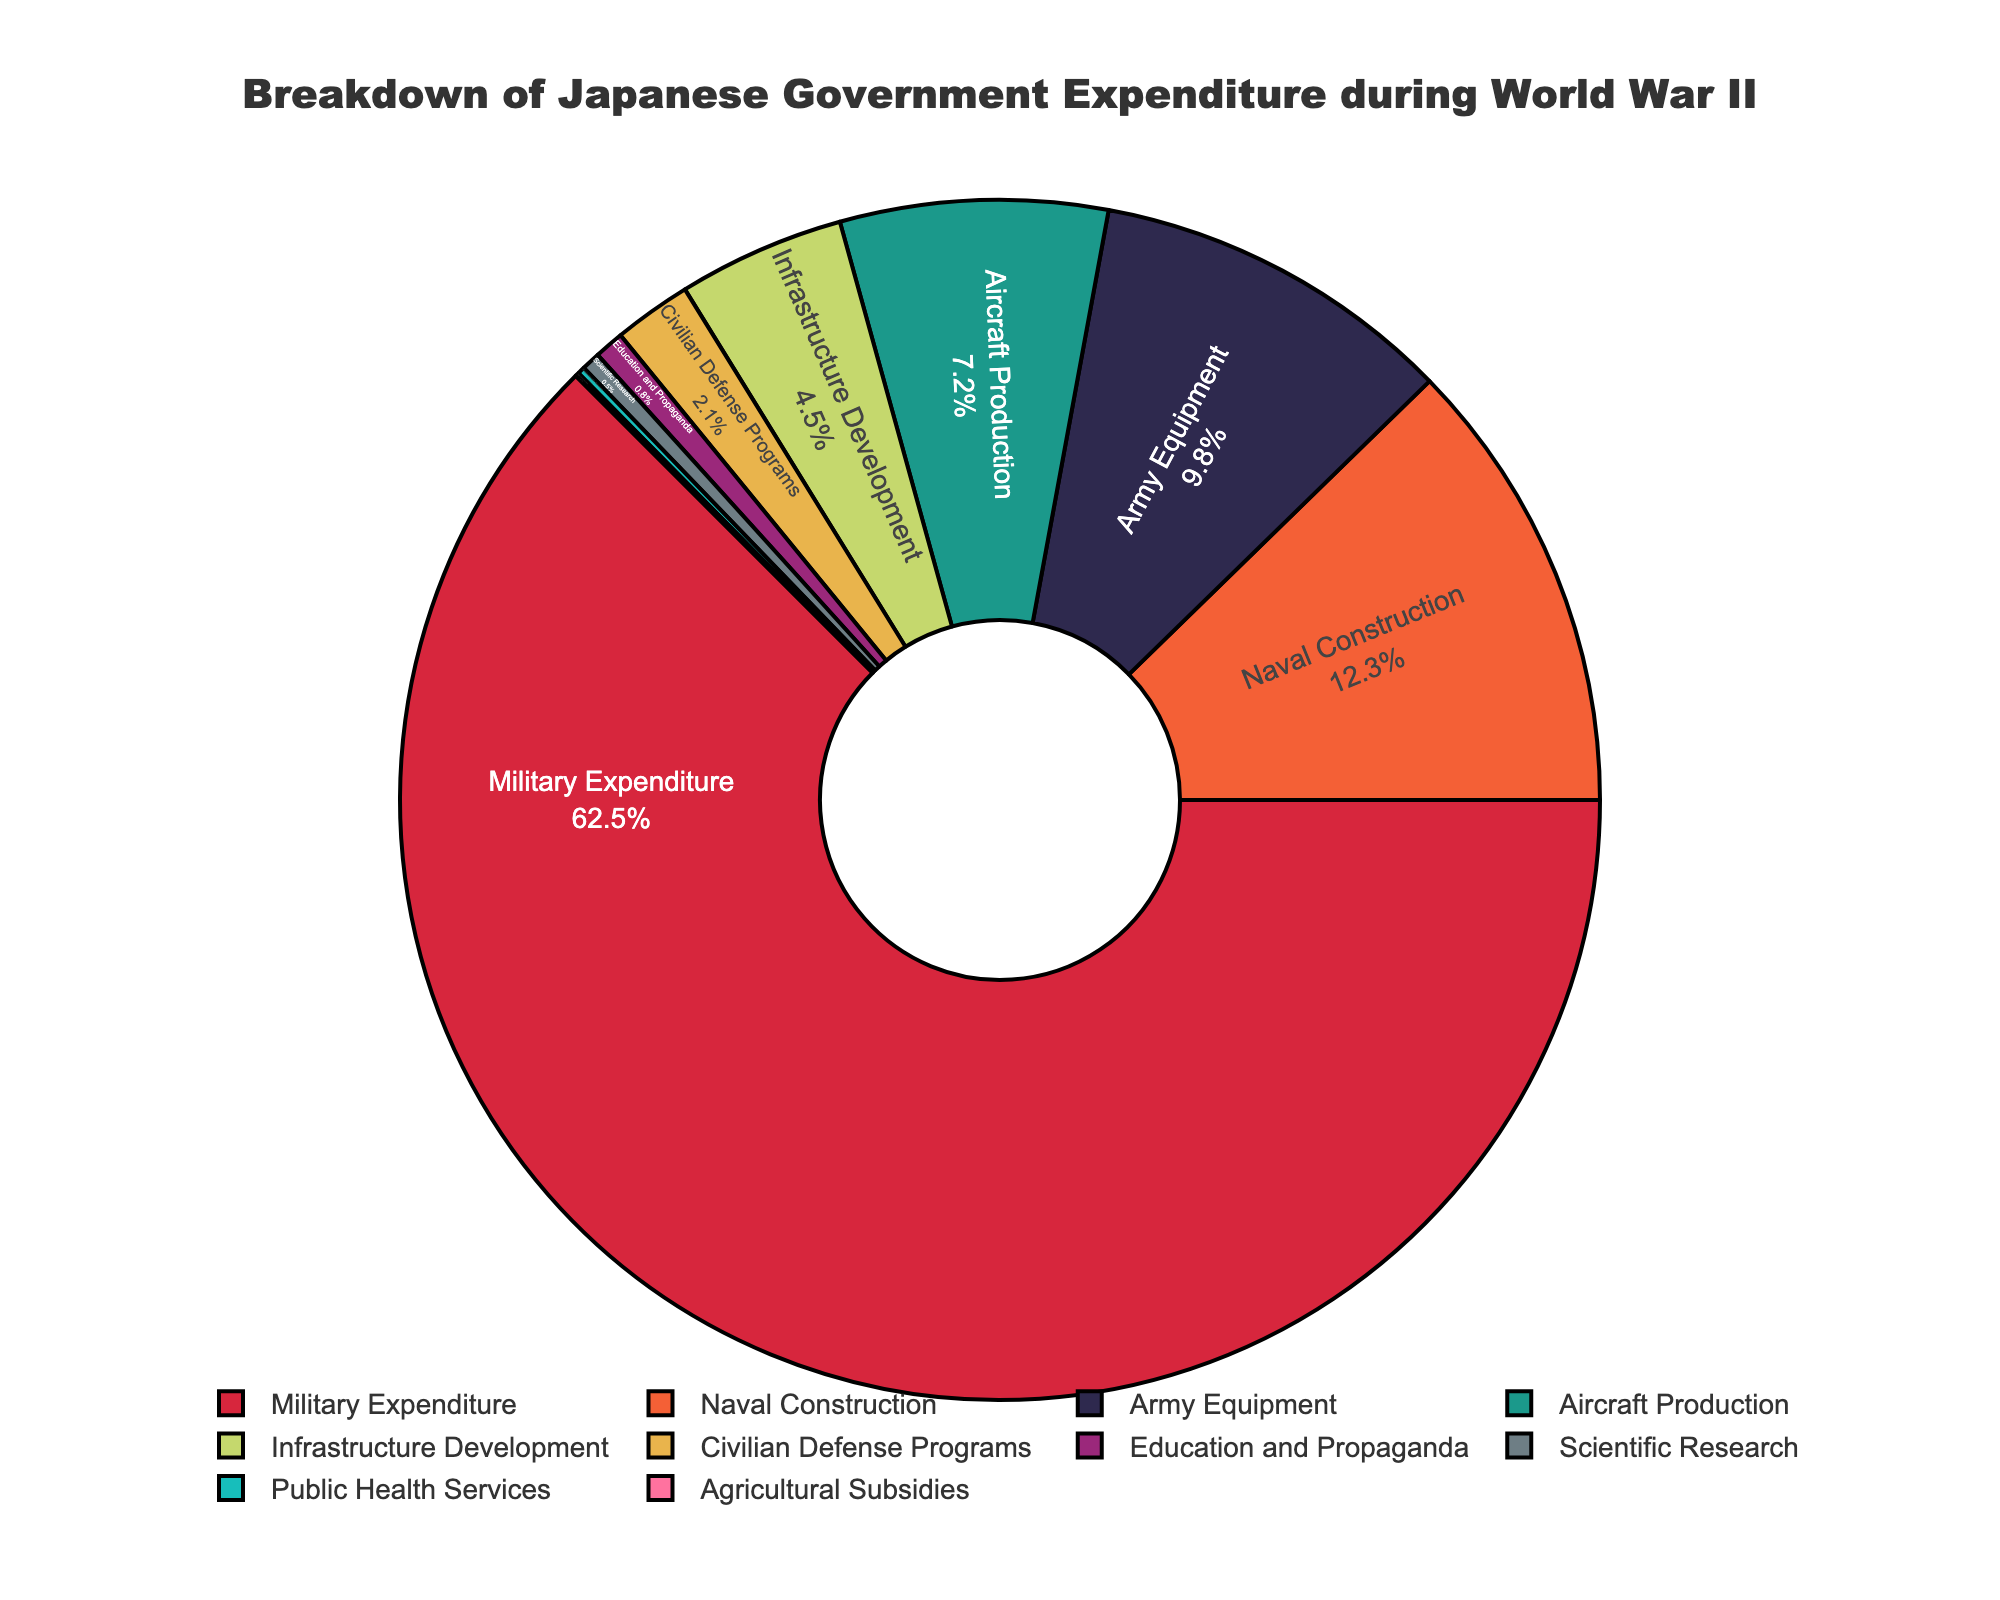Which category has the highest percentage of government expenditure during World War II? The largest segment of the pie chart corresponds to the Military Expenditure category, indicating the highest percentage.
Answer: Military Expenditure How much higher is the Military Expenditure compared to Naval Construction? Military Expenditure is 62.5%, and Naval Construction is 12.3%. Subtracting these values gives (62.5 - 12.3) = 50.2%.
Answer: 50.2% What is the combined percentage of Naval Construction, Army Equipment, and Aircraft Production? Adding the values for Naval Construction (12.3%), Army Equipment (9.8%), and Aircraft Production (7.2%) results in (12.3 + 9.8 + 7.2) = 29.3%.
Answer: 29.3% Which sectors combined have a total expenditure percentage lower than Infrastructure Development? Adding the percentages for Public Health Services (0.2%) and Agricultural Subsidies (0.1%) results in (0.2 + 0.1) = 0.3%, which is lower than Infrastructure Development's 4.5%.
Answer: Public Health Services and Agricultural Subsidies How does the expenditure on Aircraft Production compare to that on Education and Propaganda? The expenditure on Aircraft Production is 7.2%, while on Education and Propaganda, it is 0.8%, making Aircraft Production (7.2 - 0.8) = 6.4% higher.
Answer: 6.4% higher What is the total percentage allocated to categories that are not directly related to military spending? Summing the percentages for Infrastructure Development (4.5%), Civilian Defense Programs (2.1%), Education and Propaganda (0.8%), Scientific Research (0.5%), Public Health Services (0.2%), and Agricultural Subsidies (0.1%) results in (4.5 + 2.1 + 0.8 + 0.5 + 0.2 + 0.1) = 8.2%.
Answer: 8.2% Among the listed categories, which one has the smallest allocation and what is its value? The smallest segment of the pie chart corresponds to Agricultural Subsidies with a value of 0.1%.
Answer: Agricultural Subsidies, 0.1% Is the percentage of expenditure on Scientific Research and Public Health Services combined greater than that of Civilian Defense Programs? Adding the percentages for Scientific Research (0.5%) and Public Health Services (0.2%) results in (0.5 + 0.2) = 0.7%, which is less than the percentage for Civilian Defense Programs (2.1%).
Answer: No, 0.7% is less than 2.1% Which category is represented by the green segment in the pie chart? According to the custom color palette, the green segment is attributed to Aircraft Production.
Answer: Aircraft Production What is the difference in percentage between the category with the second highest expenditure and the category with the lowest expenditure? The second highest expenditure category is Naval Construction at 12.3%, and the lowest is Agricultural Subsidies at 0.1%. The difference is (12.3 - 0.1) = 12.2%.
Answer: 12.2% 